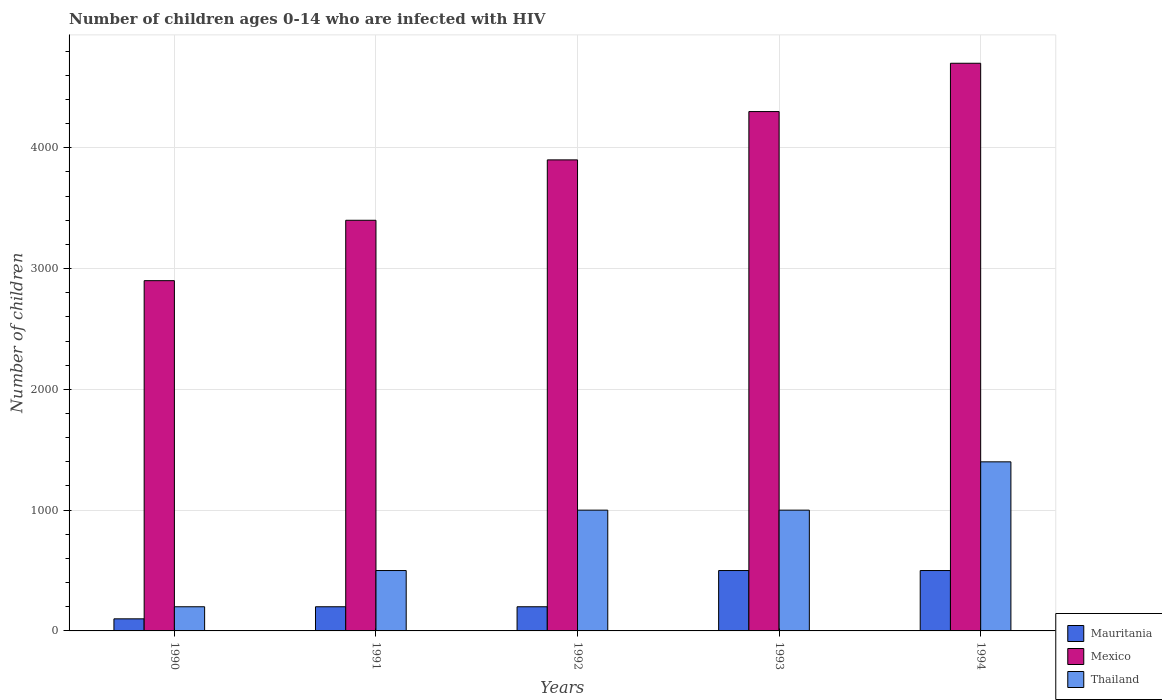How many different coloured bars are there?
Make the answer very short. 3. Are the number of bars per tick equal to the number of legend labels?
Give a very brief answer. Yes. In how many cases, is the number of bars for a given year not equal to the number of legend labels?
Make the answer very short. 0. What is the number of HIV infected children in Mauritania in 1991?
Your answer should be very brief. 200. Across all years, what is the maximum number of HIV infected children in Mexico?
Your response must be concise. 4700. Across all years, what is the minimum number of HIV infected children in Mauritania?
Provide a short and direct response. 100. In which year was the number of HIV infected children in Mexico maximum?
Keep it short and to the point. 1994. What is the total number of HIV infected children in Mexico in the graph?
Give a very brief answer. 1.92e+04. What is the difference between the number of HIV infected children in Thailand in 1990 and that in 1992?
Offer a very short reply. -800. What is the difference between the number of HIV infected children in Thailand in 1992 and the number of HIV infected children in Mexico in 1991?
Provide a succinct answer. -2400. What is the average number of HIV infected children in Thailand per year?
Give a very brief answer. 820. In the year 1992, what is the difference between the number of HIV infected children in Thailand and number of HIV infected children in Mauritania?
Your answer should be compact. 800. In how many years, is the number of HIV infected children in Thailand greater than 4000?
Offer a very short reply. 0. What is the ratio of the number of HIV infected children in Mexico in 1991 to that in 1993?
Provide a short and direct response. 0.79. Is the number of HIV infected children in Thailand in 1990 less than that in 1993?
Make the answer very short. Yes. Is the difference between the number of HIV infected children in Thailand in 1990 and 1994 greater than the difference between the number of HIV infected children in Mauritania in 1990 and 1994?
Your response must be concise. No. What is the difference between the highest and the second highest number of HIV infected children in Mauritania?
Give a very brief answer. 0. What is the difference between the highest and the lowest number of HIV infected children in Mauritania?
Give a very brief answer. 400. Is the sum of the number of HIV infected children in Mauritania in 1992 and 1993 greater than the maximum number of HIV infected children in Mexico across all years?
Offer a terse response. No. What does the 1st bar from the right in 1991 represents?
Ensure brevity in your answer.  Thailand. Is it the case that in every year, the sum of the number of HIV infected children in Mexico and number of HIV infected children in Mauritania is greater than the number of HIV infected children in Thailand?
Your response must be concise. Yes. Are the values on the major ticks of Y-axis written in scientific E-notation?
Give a very brief answer. No. Does the graph contain grids?
Provide a short and direct response. Yes. Where does the legend appear in the graph?
Your answer should be very brief. Bottom right. How are the legend labels stacked?
Offer a very short reply. Vertical. What is the title of the graph?
Keep it short and to the point. Number of children ages 0-14 who are infected with HIV. What is the label or title of the Y-axis?
Your answer should be very brief. Number of children. What is the Number of children in Mauritania in 1990?
Your answer should be compact. 100. What is the Number of children in Mexico in 1990?
Give a very brief answer. 2900. What is the Number of children of Thailand in 1990?
Ensure brevity in your answer.  200. What is the Number of children of Mexico in 1991?
Your answer should be compact. 3400. What is the Number of children in Thailand in 1991?
Provide a short and direct response. 500. What is the Number of children in Mauritania in 1992?
Offer a very short reply. 200. What is the Number of children of Mexico in 1992?
Give a very brief answer. 3900. What is the Number of children in Mauritania in 1993?
Keep it short and to the point. 500. What is the Number of children of Mexico in 1993?
Provide a succinct answer. 4300. What is the Number of children in Thailand in 1993?
Keep it short and to the point. 1000. What is the Number of children of Mexico in 1994?
Make the answer very short. 4700. What is the Number of children of Thailand in 1994?
Give a very brief answer. 1400. Across all years, what is the maximum Number of children of Mexico?
Offer a very short reply. 4700. Across all years, what is the maximum Number of children of Thailand?
Your response must be concise. 1400. Across all years, what is the minimum Number of children of Mexico?
Your answer should be very brief. 2900. What is the total Number of children in Mauritania in the graph?
Offer a terse response. 1500. What is the total Number of children of Mexico in the graph?
Your answer should be compact. 1.92e+04. What is the total Number of children in Thailand in the graph?
Provide a succinct answer. 4100. What is the difference between the Number of children of Mauritania in 1990 and that in 1991?
Ensure brevity in your answer.  -100. What is the difference between the Number of children of Mexico in 1990 and that in 1991?
Make the answer very short. -500. What is the difference between the Number of children in Thailand in 1990 and that in 1991?
Make the answer very short. -300. What is the difference between the Number of children of Mauritania in 1990 and that in 1992?
Keep it short and to the point. -100. What is the difference between the Number of children in Mexico in 1990 and that in 1992?
Your response must be concise. -1000. What is the difference between the Number of children of Thailand in 1990 and that in 1992?
Your answer should be very brief. -800. What is the difference between the Number of children of Mauritania in 1990 and that in 1993?
Make the answer very short. -400. What is the difference between the Number of children of Mexico in 1990 and that in 1993?
Keep it short and to the point. -1400. What is the difference between the Number of children in Thailand in 1990 and that in 1993?
Your answer should be very brief. -800. What is the difference between the Number of children of Mauritania in 1990 and that in 1994?
Your response must be concise. -400. What is the difference between the Number of children of Mexico in 1990 and that in 1994?
Your answer should be very brief. -1800. What is the difference between the Number of children in Thailand in 1990 and that in 1994?
Offer a very short reply. -1200. What is the difference between the Number of children in Mauritania in 1991 and that in 1992?
Offer a very short reply. 0. What is the difference between the Number of children of Mexico in 1991 and that in 1992?
Make the answer very short. -500. What is the difference between the Number of children of Thailand in 1991 and that in 1992?
Your answer should be very brief. -500. What is the difference between the Number of children in Mauritania in 1991 and that in 1993?
Offer a terse response. -300. What is the difference between the Number of children in Mexico in 1991 and that in 1993?
Ensure brevity in your answer.  -900. What is the difference between the Number of children in Thailand in 1991 and that in 1993?
Your response must be concise. -500. What is the difference between the Number of children in Mauritania in 1991 and that in 1994?
Your response must be concise. -300. What is the difference between the Number of children of Mexico in 1991 and that in 1994?
Provide a succinct answer. -1300. What is the difference between the Number of children of Thailand in 1991 and that in 1994?
Your answer should be compact. -900. What is the difference between the Number of children in Mauritania in 1992 and that in 1993?
Your answer should be very brief. -300. What is the difference between the Number of children in Mexico in 1992 and that in 1993?
Ensure brevity in your answer.  -400. What is the difference between the Number of children of Thailand in 1992 and that in 1993?
Ensure brevity in your answer.  0. What is the difference between the Number of children of Mauritania in 1992 and that in 1994?
Your answer should be compact. -300. What is the difference between the Number of children in Mexico in 1992 and that in 1994?
Ensure brevity in your answer.  -800. What is the difference between the Number of children of Thailand in 1992 and that in 1994?
Your answer should be compact. -400. What is the difference between the Number of children of Mauritania in 1993 and that in 1994?
Ensure brevity in your answer.  0. What is the difference between the Number of children of Mexico in 1993 and that in 1994?
Give a very brief answer. -400. What is the difference between the Number of children of Thailand in 1993 and that in 1994?
Keep it short and to the point. -400. What is the difference between the Number of children in Mauritania in 1990 and the Number of children in Mexico in 1991?
Offer a terse response. -3300. What is the difference between the Number of children of Mauritania in 1990 and the Number of children of Thailand in 1991?
Ensure brevity in your answer.  -400. What is the difference between the Number of children in Mexico in 1990 and the Number of children in Thailand in 1991?
Offer a very short reply. 2400. What is the difference between the Number of children in Mauritania in 1990 and the Number of children in Mexico in 1992?
Your answer should be compact. -3800. What is the difference between the Number of children in Mauritania in 1990 and the Number of children in Thailand in 1992?
Your response must be concise. -900. What is the difference between the Number of children in Mexico in 1990 and the Number of children in Thailand in 1992?
Keep it short and to the point. 1900. What is the difference between the Number of children in Mauritania in 1990 and the Number of children in Mexico in 1993?
Your answer should be very brief. -4200. What is the difference between the Number of children in Mauritania in 1990 and the Number of children in Thailand in 1993?
Your answer should be compact. -900. What is the difference between the Number of children of Mexico in 1990 and the Number of children of Thailand in 1993?
Offer a very short reply. 1900. What is the difference between the Number of children in Mauritania in 1990 and the Number of children in Mexico in 1994?
Your response must be concise. -4600. What is the difference between the Number of children of Mauritania in 1990 and the Number of children of Thailand in 1994?
Ensure brevity in your answer.  -1300. What is the difference between the Number of children of Mexico in 1990 and the Number of children of Thailand in 1994?
Offer a very short reply. 1500. What is the difference between the Number of children of Mauritania in 1991 and the Number of children of Mexico in 1992?
Offer a terse response. -3700. What is the difference between the Number of children in Mauritania in 1991 and the Number of children in Thailand in 1992?
Your response must be concise. -800. What is the difference between the Number of children of Mexico in 1991 and the Number of children of Thailand in 1992?
Keep it short and to the point. 2400. What is the difference between the Number of children of Mauritania in 1991 and the Number of children of Mexico in 1993?
Give a very brief answer. -4100. What is the difference between the Number of children in Mauritania in 1991 and the Number of children in Thailand in 1993?
Provide a succinct answer. -800. What is the difference between the Number of children of Mexico in 1991 and the Number of children of Thailand in 1993?
Give a very brief answer. 2400. What is the difference between the Number of children of Mauritania in 1991 and the Number of children of Mexico in 1994?
Your response must be concise. -4500. What is the difference between the Number of children of Mauritania in 1991 and the Number of children of Thailand in 1994?
Ensure brevity in your answer.  -1200. What is the difference between the Number of children in Mexico in 1991 and the Number of children in Thailand in 1994?
Your answer should be very brief. 2000. What is the difference between the Number of children in Mauritania in 1992 and the Number of children in Mexico in 1993?
Keep it short and to the point. -4100. What is the difference between the Number of children in Mauritania in 1992 and the Number of children in Thailand in 1993?
Your answer should be compact. -800. What is the difference between the Number of children of Mexico in 1992 and the Number of children of Thailand in 1993?
Ensure brevity in your answer.  2900. What is the difference between the Number of children in Mauritania in 1992 and the Number of children in Mexico in 1994?
Offer a terse response. -4500. What is the difference between the Number of children in Mauritania in 1992 and the Number of children in Thailand in 1994?
Make the answer very short. -1200. What is the difference between the Number of children of Mexico in 1992 and the Number of children of Thailand in 1994?
Your answer should be compact. 2500. What is the difference between the Number of children of Mauritania in 1993 and the Number of children of Mexico in 1994?
Your answer should be very brief. -4200. What is the difference between the Number of children of Mauritania in 1993 and the Number of children of Thailand in 1994?
Your answer should be very brief. -900. What is the difference between the Number of children of Mexico in 1993 and the Number of children of Thailand in 1994?
Provide a short and direct response. 2900. What is the average Number of children of Mauritania per year?
Your answer should be very brief. 300. What is the average Number of children in Mexico per year?
Your answer should be very brief. 3840. What is the average Number of children in Thailand per year?
Give a very brief answer. 820. In the year 1990, what is the difference between the Number of children in Mauritania and Number of children in Mexico?
Make the answer very short. -2800. In the year 1990, what is the difference between the Number of children in Mauritania and Number of children in Thailand?
Give a very brief answer. -100. In the year 1990, what is the difference between the Number of children of Mexico and Number of children of Thailand?
Make the answer very short. 2700. In the year 1991, what is the difference between the Number of children of Mauritania and Number of children of Mexico?
Offer a very short reply. -3200. In the year 1991, what is the difference between the Number of children in Mauritania and Number of children in Thailand?
Ensure brevity in your answer.  -300. In the year 1991, what is the difference between the Number of children of Mexico and Number of children of Thailand?
Your response must be concise. 2900. In the year 1992, what is the difference between the Number of children of Mauritania and Number of children of Mexico?
Your answer should be compact. -3700. In the year 1992, what is the difference between the Number of children in Mauritania and Number of children in Thailand?
Make the answer very short. -800. In the year 1992, what is the difference between the Number of children in Mexico and Number of children in Thailand?
Your answer should be very brief. 2900. In the year 1993, what is the difference between the Number of children in Mauritania and Number of children in Mexico?
Provide a short and direct response. -3800. In the year 1993, what is the difference between the Number of children in Mauritania and Number of children in Thailand?
Offer a very short reply. -500. In the year 1993, what is the difference between the Number of children in Mexico and Number of children in Thailand?
Ensure brevity in your answer.  3300. In the year 1994, what is the difference between the Number of children of Mauritania and Number of children of Mexico?
Offer a terse response. -4200. In the year 1994, what is the difference between the Number of children in Mauritania and Number of children in Thailand?
Your answer should be compact. -900. In the year 1994, what is the difference between the Number of children of Mexico and Number of children of Thailand?
Ensure brevity in your answer.  3300. What is the ratio of the Number of children of Mexico in 1990 to that in 1991?
Provide a succinct answer. 0.85. What is the ratio of the Number of children of Mauritania in 1990 to that in 1992?
Offer a very short reply. 0.5. What is the ratio of the Number of children in Mexico in 1990 to that in 1992?
Your response must be concise. 0.74. What is the ratio of the Number of children of Thailand in 1990 to that in 1992?
Your answer should be very brief. 0.2. What is the ratio of the Number of children in Mexico in 1990 to that in 1993?
Give a very brief answer. 0.67. What is the ratio of the Number of children of Thailand in 1990 to that in 1993?
Make the answer very short. 0.2. What is the ratio of the Number of children in Mauritania in 1990 to that in 1994?
Your answer should be very brief. 0.2. What is the ratio of the Number of children of Mexico in 1990 to that in 1994?
Offer a terse response. 0.62. What is the ratio of the Number of children in Thailand in 1990 to that in 1994?
Provide a short and direct response. 0.14. What is the ratio of the Number of children of Mexico in 1991 to that in 1992?
Your answer should be very brief. 0.87. What is the ratio of the Number of children of Thailand in 1991 to that in 1992?
Ensure brevity in your answer.  0.5. What is the ratio of the Number of children in Mauritania in 1991 to that in 1993?
Your response must be concise. 0.4. What is the ratio of the Number of children in Mexico in 1991 to that in 1993?
Provide a succinct answer. 0.79. What is the ratio of the Number of children in Thailand in 1991 to that in 1993?
Your answer should be very brief. 0.5. What is the ratio of the Number of children of Mauritania in 1991 to that in 1994?
Provide a succinct answer. 0.4. What is the ratio of the Number of children in Mexico in 1991 to that in 1994?
Your response must be concise. 0.72. What is the ratio of the Number of children of Thailand in 1991 to that in 1994?
Provide a short and direct response. 0.36. What is the ratio of the Number of children in Mexico in 1992 to that in 1993?
Provide a short and direct response. 0.91. What is the ratio of the Number of children of Mexico in 1992 to that in 1994?
Provide a short and direct response. 0.83. What is the ratio of the Number of children in Mauritania in 1993 to that in 1994?
Make the answer very short. 1. What is the ratio of the Number of children of Mexico in 1993 to that in 1994?
Provide a short and direct response. 0.91. What is the difference between the highest and the second highest Number of children in Mauritania?
Offer a terse response. 0. What is the difference between the highest and the lowest Number of children in Mexico?
Your answer should be compact. 1800. What is the difference between the highest and the lowest Number of children in Thailand?
Keep it short and to the point. 1200. 